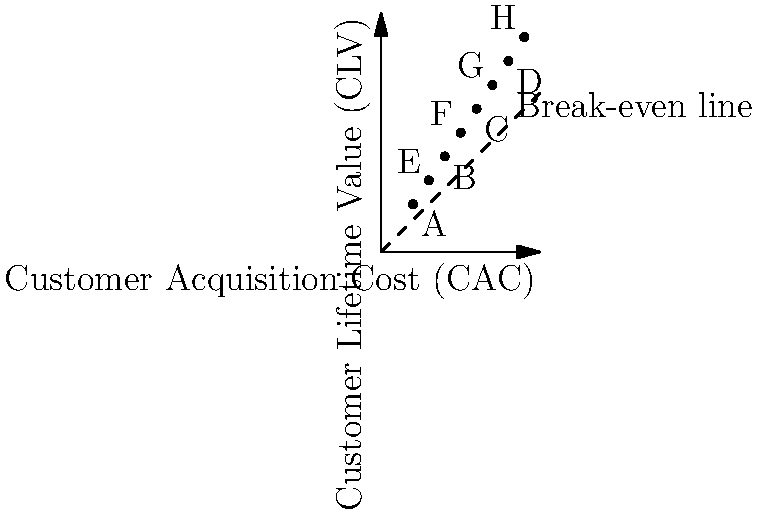As a fresh graduate entering the startup world, you're tasked with analyzing customer acquisition costs (CAC) versus customer lifetime value (CLV) for various marketing channels. The scatter plot above shows data points for 8 different channels (A-H). Which channel has the highest ratio of CLV to CAC, indicating the most efficient customer acquisition strategy? To determine the most efficient customer acquisition strategy, we need to calculate the ratio of CLV to CAC for each channel and compare them. The higher the ratio, the more efficient the strategy.

Let's calculate the CLV/CAC ratio for each channel:

A: $\frac{30}{20} = 1.5$
B: $\frac{60}{40} = 1.5$
C: $\frac{90}{60} = 1.5$
D: $\frac{120}{80} = 1.5$
E: $\frac{45}{30} = 1.5$
F: $\frac{75}{50} = 1.5$
G: $\frac{105}{70} = 1.5$
H: $\frac{135}{90} = 1.5$

Interestingly, all channels have the same CLV/CAC ratio of 1.5. This means they are all equally efficient in terms of the ratio between customer lifetime value and acquisition cost.

However, the question asks for the highest ratio, which in this case is shared by all channels. To break the tie, we should consider the channel with the highest absolute CLV and CAC values, as this represents the largest scale of operations while maintaining the same efficiency.

Channel H has the highest CLV ($135) and CAC ($90) while maintaining the 1.5 ratio, making it the most impactful choice in terms of scale.
Answer: Channel H 